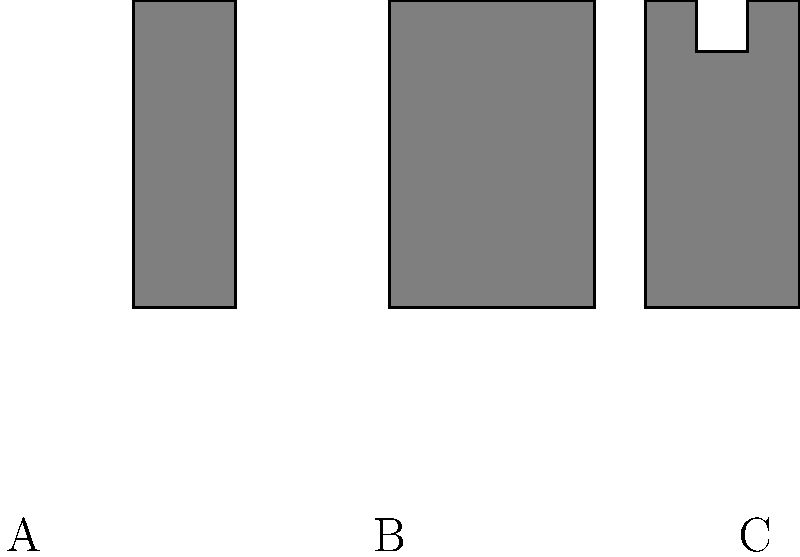Which of the silhouettes above represents a spatula, commonly used for flipping pancakes or burgers? To identify the spatula, let's analyze each silhouette:

1. Silhouette A: This shape is long and narrow with a small rectangular head. It resembles a wooden spoon or a mixing spoon, which is used for stirring and mixing ingredients.

2. Silhouette B: This shape has a wide, flat rectangular head attached to a handle. This is the characteristic shape of a spatula, which is designed for flipping, turning, and transferring food items like pancakes or burgers.

3. Silhouette C: This silhouette shows a utensil with a long handle and a forked end. This shape is typical of a carving fork or a serving fork, used for holding meat in place while carving or for serving large pieces of food.

Based on these observations, the silhouette that represents a spatula, commonly used for flipping pancakes or burgers, is Silhouette B.
Answer: B 